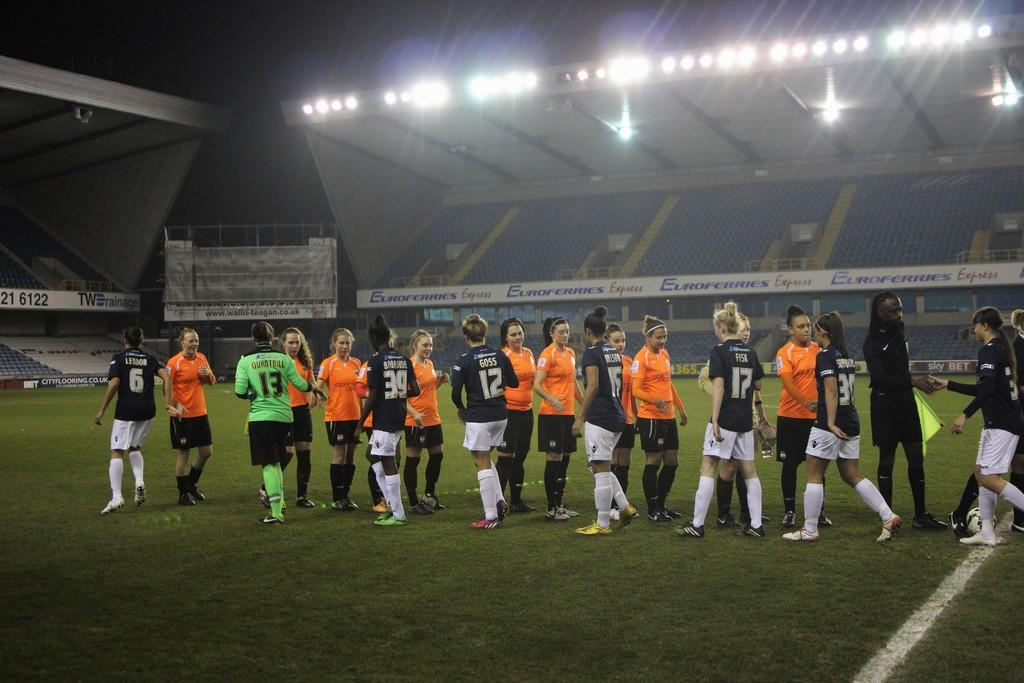What is the main subject of the image? There are people in the center of the image. What type of surface is visible at the bottom of the image? There is grass at the bottom of the image. What can be seen in the background of the image? There are stands in the background of the image. What is visible at the top of the image? There are lights at the top of the image. Can you see any corn growing in the image? There is no corn visible in the image. What type of curve can be seen in the image? There is no curve present in the image. 